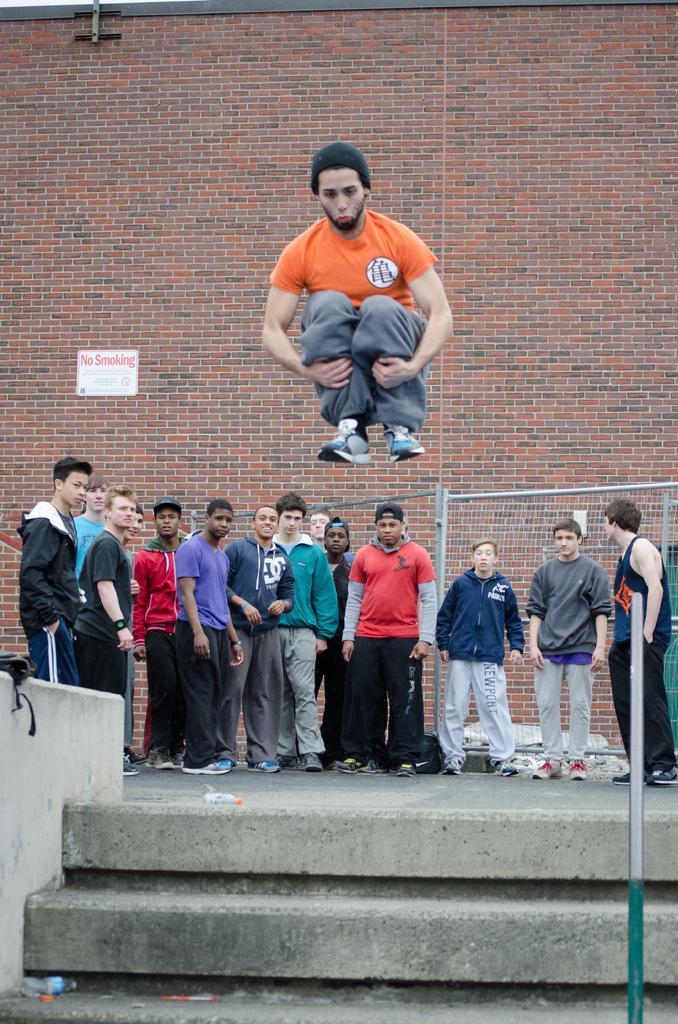Can you describe this image briefly? In this image there is a person jumping in the air. There are bottles on the stairs. There is a pole. There is some object on the wall. There are a few people standing. Behind them there is a metal fence. In the background of the image there is a no smoking board on the wall. 